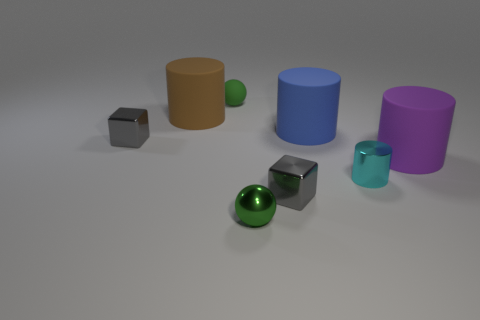Subtract all gray cubes. How many were subtracted if there are1gray cubes left? 1 Subtract 1 cylinders. How many cylinders are left? 3 Add 1 big brown cylinders. How many objects exist? 9 Subtract all cubes. How many objects are left? 6 Add 6 small green things. How many small green things exist? 8 Subtract 1 cyan cylinders. How many objects are left? 7 Subtract all shiny objects. Subtract all matte cylinders. How many objects are left? 1 Add 4 tiny matte objects. How many tiny matte objects are left? 5 